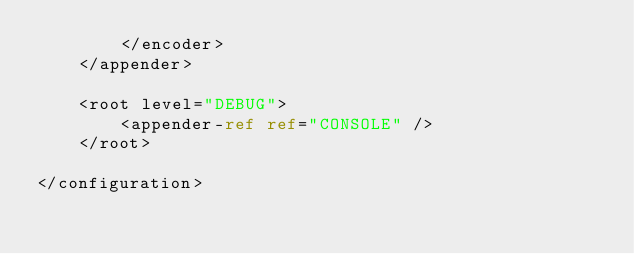<code> <loc_0><loc_0><loc_500><loc_500><_XML_>        </encoder>
    </appender>

    <root level="DEBUG">
        <appender-ref ref="CONSOLE" />
    </root>

</configuration></code> 